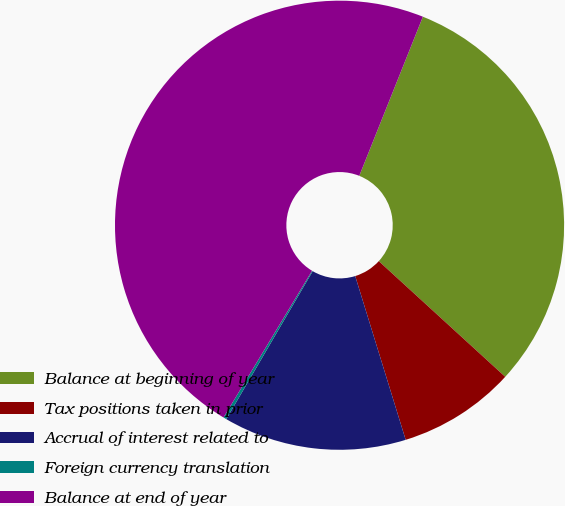Convert chart. <chart><loc_0><loc_0><loc_500><loc_500><pie_chart><fcel>Balance at beginning of year<fcel>Tax positions taken in prior<fcel>Accrual of interest related to<fcel>Foreign currency translation<fcel>Balance at end of year<nl><fcel>30.74%<fcel>8.45%<fcel>13.17%<fcel>0.23%<fcel>47.41%<nl></chart> 